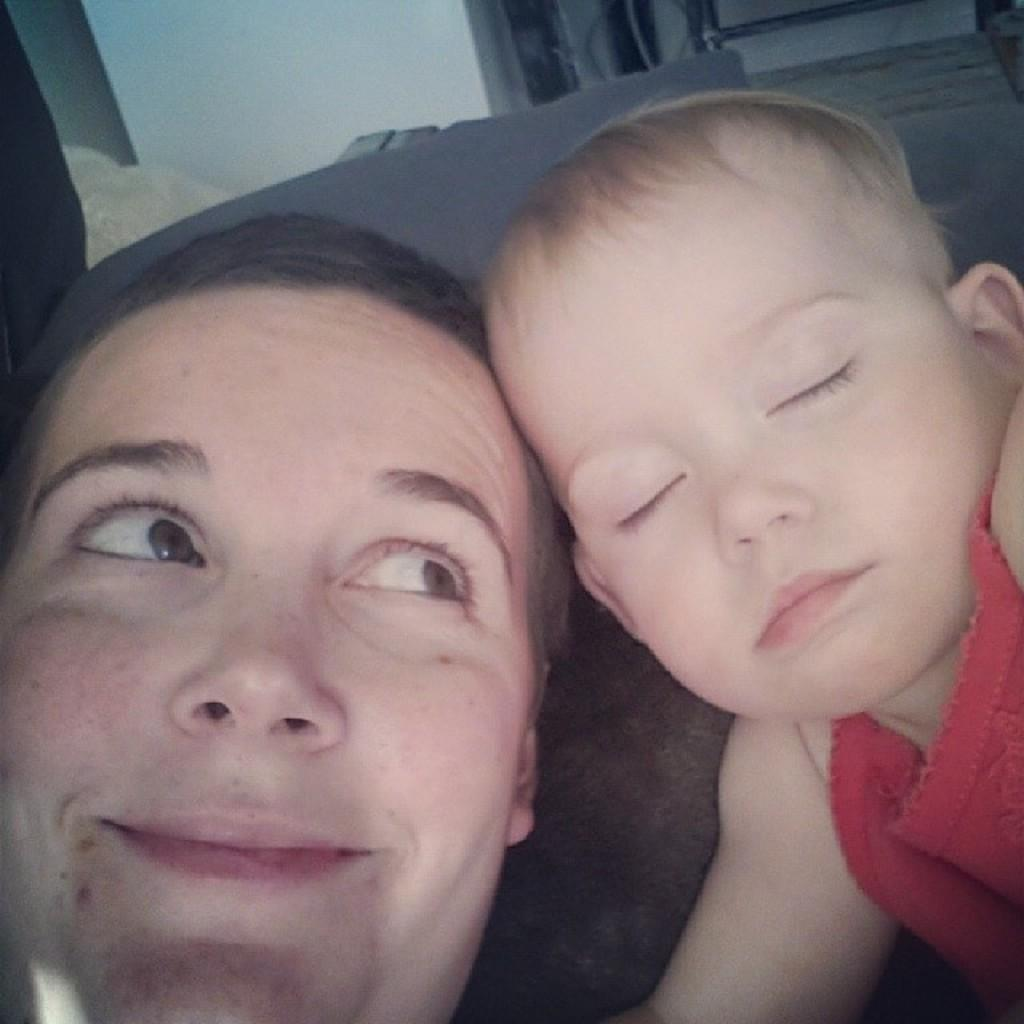What is the main subject of the image? There is a baby in the image. Who else is present in the image? There is a woman in the image. What is the woman doing in the image? The woman is looking at the baby. How is the baby depicted in the image? The baby is sleeping. What type of achiever is the baby in the image? There is no indication in the image that the baby is an achiever, as the baby is depicted as sleeping. Can you tell me how many trucks are visible in the image? There are no trucks present in the image. 